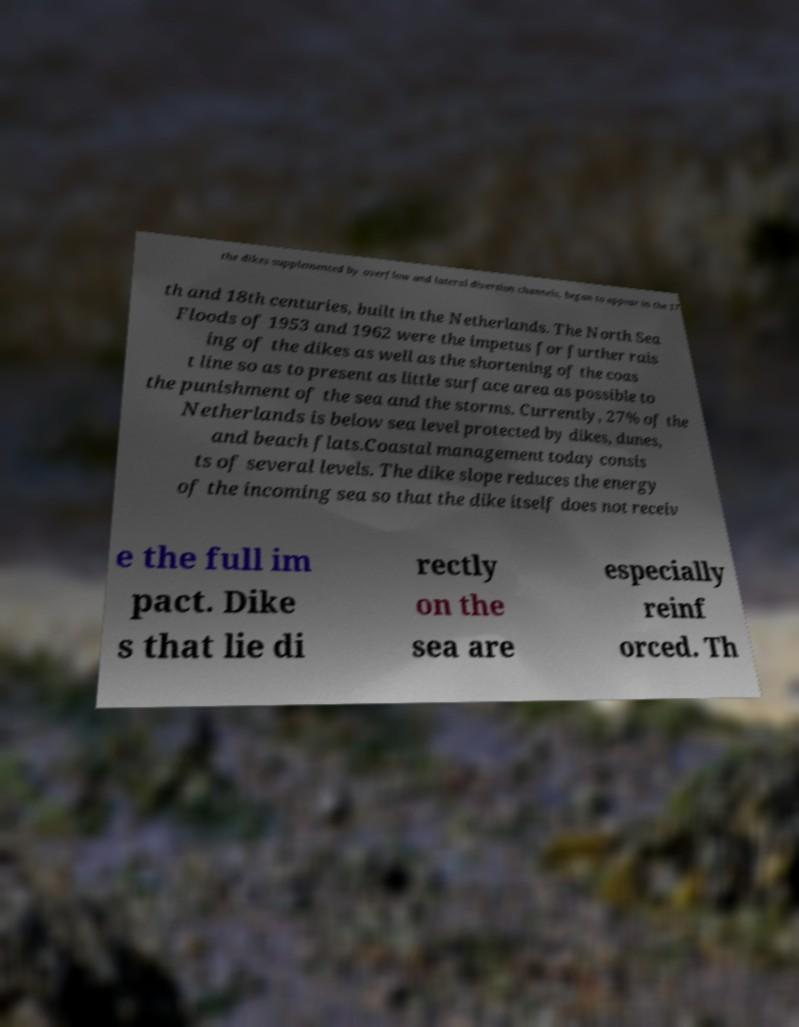I need the written content from this picture converted into text. Can you do that? the dikes supplemented by overflow and lateral diversion channels, began to appear in the 17 th and 18th centuries, built in the Netherlands. The North Sea Floods of 1953 and 1962 were the impetus for further rais ing of the dikes as well as the shortening of the coas t line so as to present as little surface area as possible to the punishment of the sea and the storms. Currently, 27% of the Netherlands is below sea level protected by dikes, dunes, and beach flats.Coastal management today consis ts of several levels. The dike slope reduces the energy of the incoming sea so that the dike itself does not receiv e the full im pact. Dike s that lie di rectly on the sea are especially reinf orced. Th 